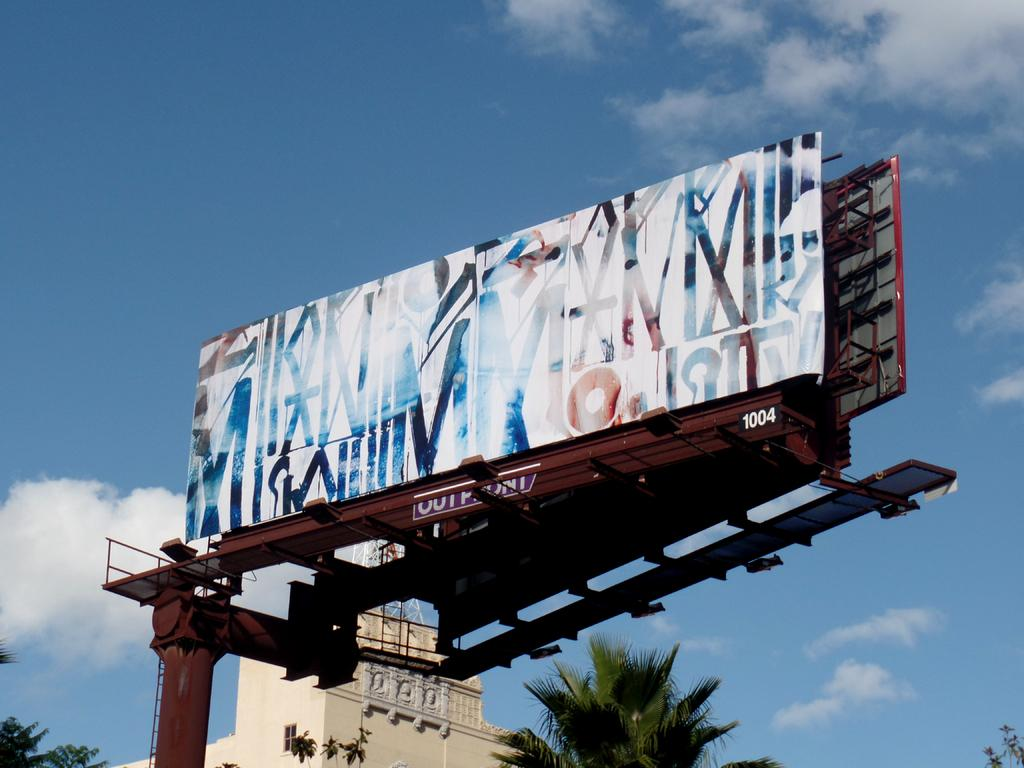<image>
Summarize the visual content of the image. Billboard image with the letters Outfront # 1004. 